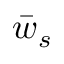<formula> <loc_0><loc_0><loc_500><loc_500>\bar { w } _ { s }</formula> 